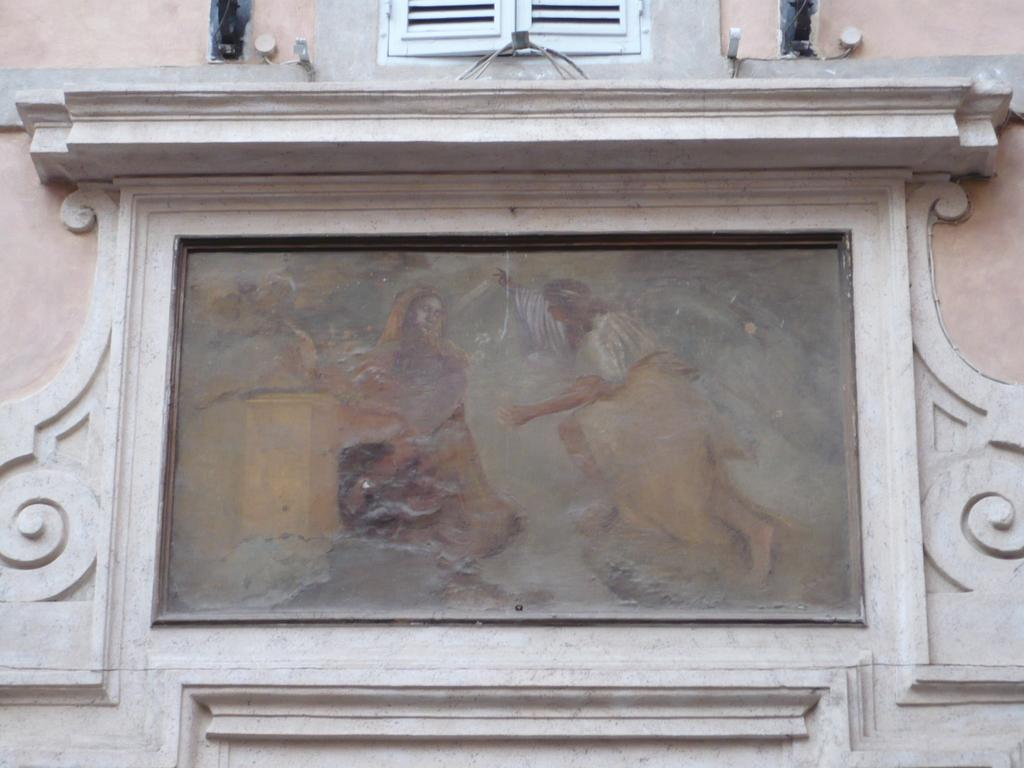What is the main subject in the center of the image? There is a portrait in the center of the image. Can you describe any other features in the image? There is a window at the top side of the image. What type of grain is being harvested in the image? There is no grain or harvesting activity present in the image; it features a portrait and a window. How many wrens can be seen perched on the window in the image? There are no wrens present in the image; it only features a portrait and a window. 